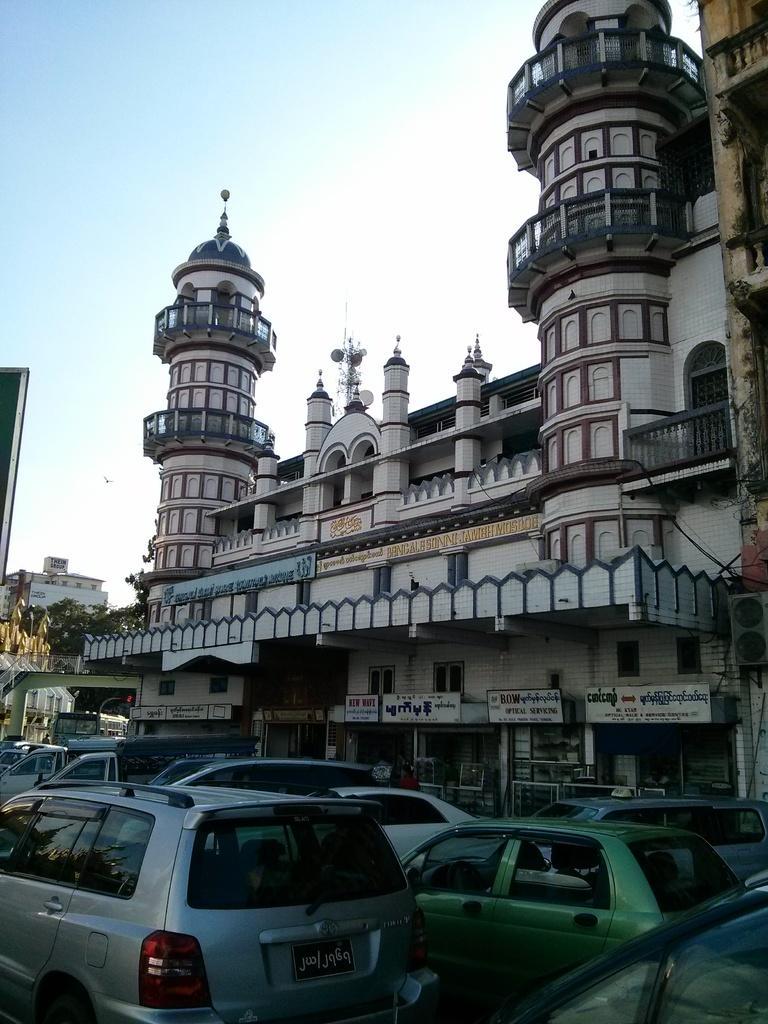Please provide a concise description of this image. In this image in the center there are buildings and trees, and also there are some boards. And at the bottom of the image there are some vehicles, and at the top there is sky and also we could see objects. 